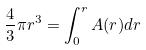<formula> <loc_0><loc_0><loc_500><loc_500>\frac { 4 } { 3 } \pi r ^ { 3 } = \int _ { 0 } ^ { r } A ( r ) d r</formula> 